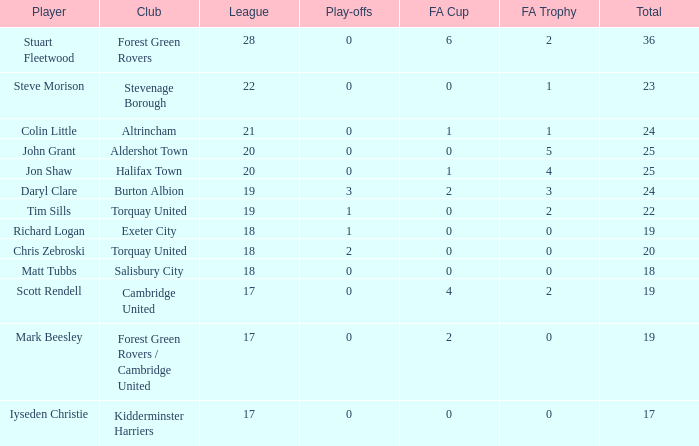What mean total had a league number of 18, Richard Logan as a player, and a play-offs number smaller than 1? None. 